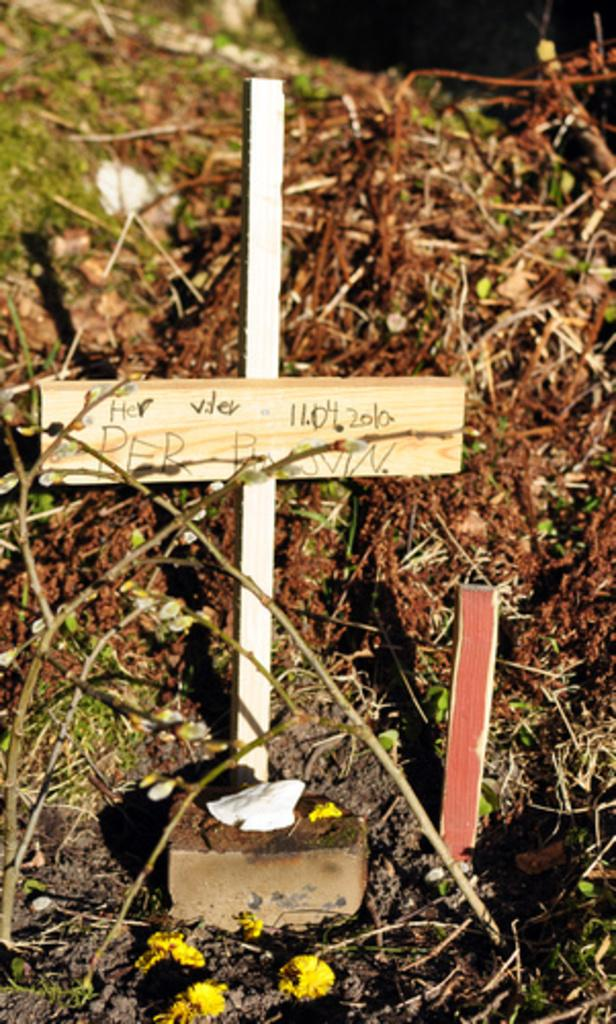What is the main object in the image? There is a wood piece with text in the image. How is the wood piece positioned? The wood piece is placed on a pole. What can be seen in the background of the image? There is a group of trees and flowers on the ground in the background of the image. What type of smell can be detected from the wood piece in the image? There is no information about the smell of the wood piece in the image, so it cannot be determined. 